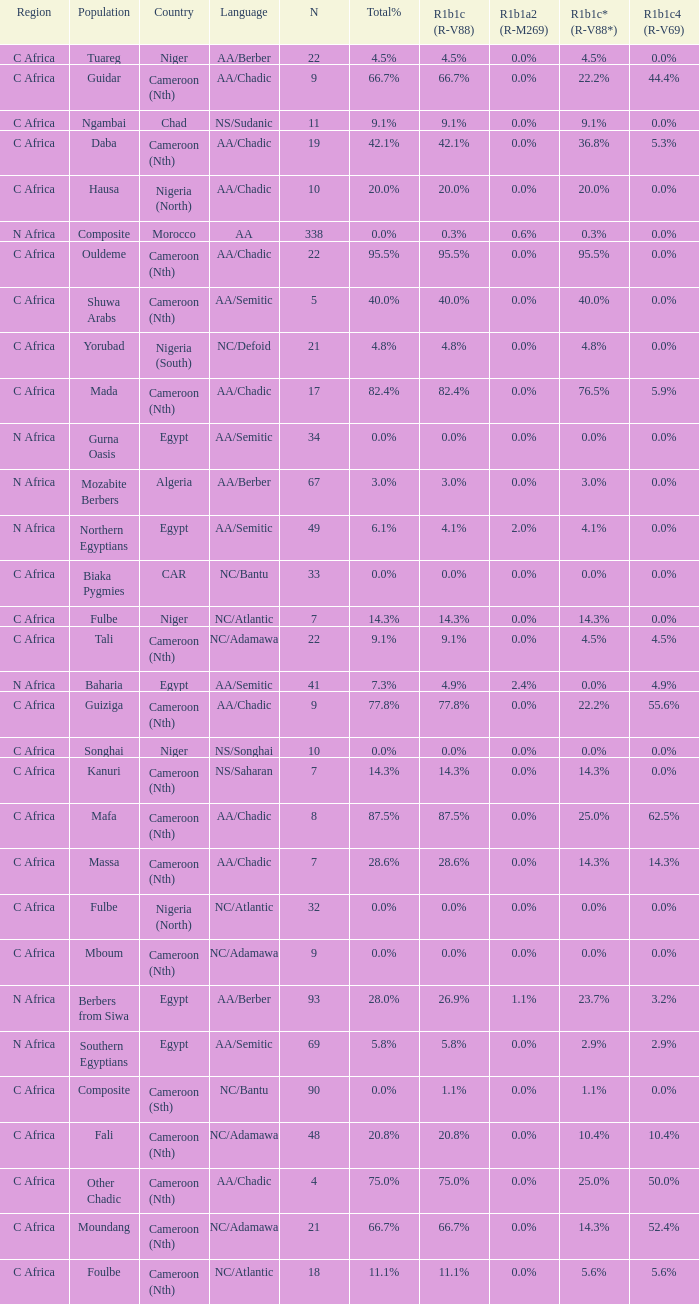What percentage is listed in column r1b1c (r-v88) for the 4.5% total percentage? 4.5%. 